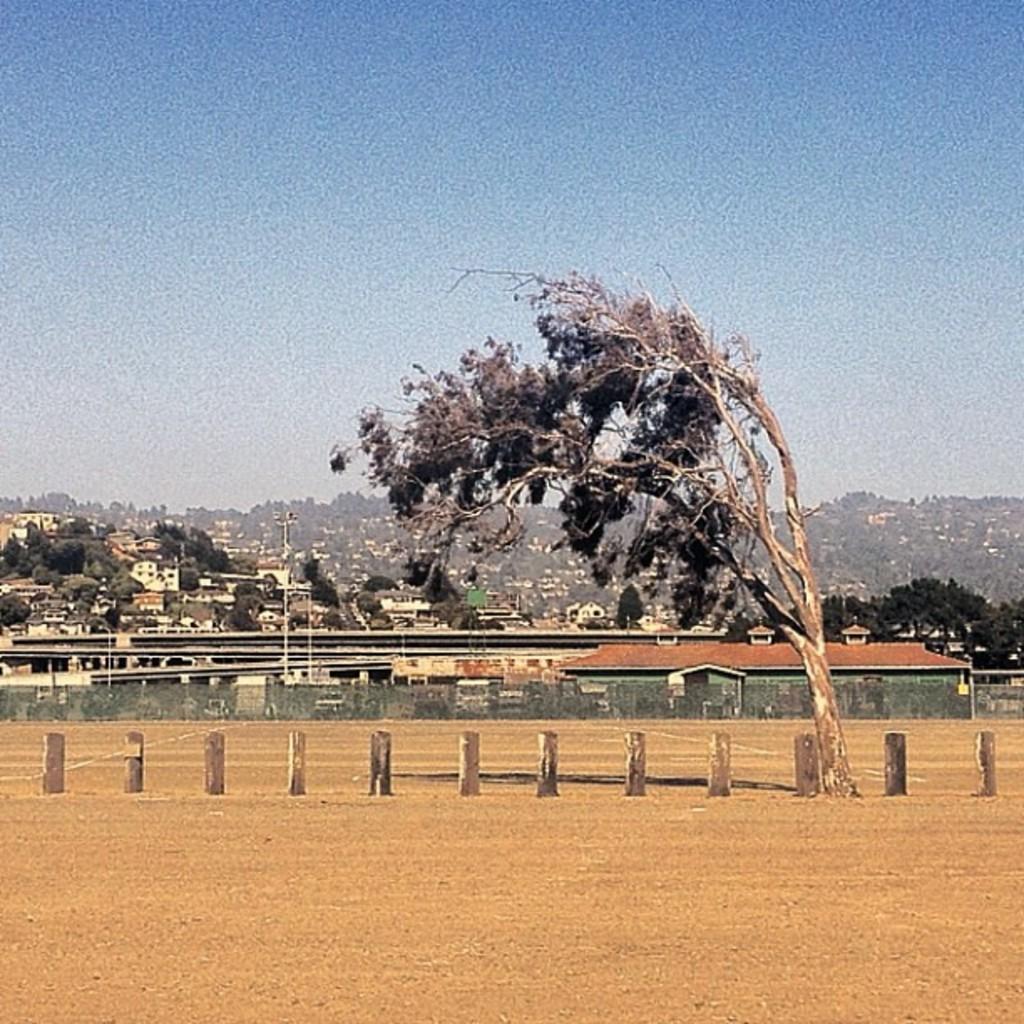In one or two sentences, can you explain what this image depicts? In this image there are rods on the ground. Beside the road there is a tree. Behind them there is a net. Behind the net there are buildings, trees and pole. In the background there are mountains. At the top there is the sky. 